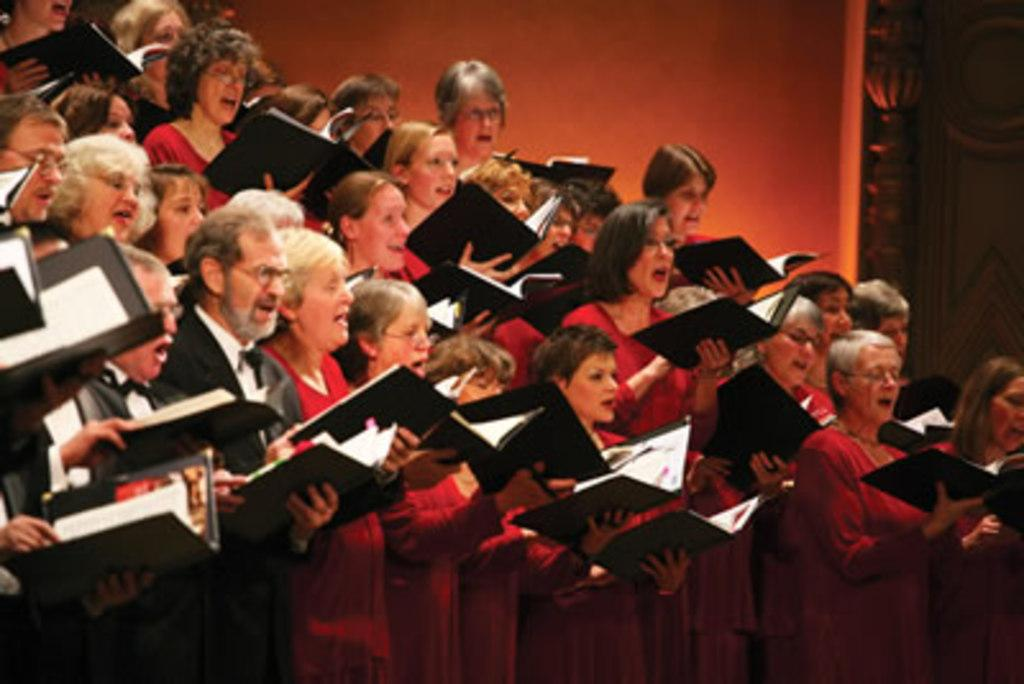What are the people in the image doing? The people in the image are standing and holding books. What can be seen behind the people in the image? There is a wall visible in the image. Is there any entrance or exit visible in the image? Yes, there is a door beside the wall. How many babies are crawling on the floor in the image? There are no babies present in the image. What type of expert is giving a lecture in the image? There is no expert giving a lecture in the image; the people are simply standing and holding books. 